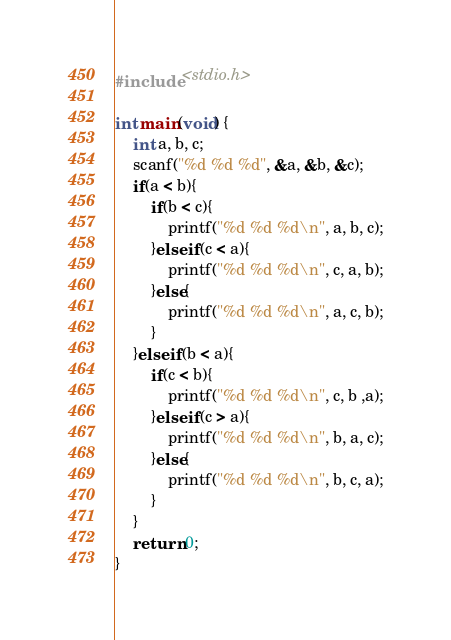Convert code to text. <code><loc_0><loc_0><loc_500><loc_500><_C_>#include <stdio.h>

int main(void) {
	int a, b, c;
	scanf("%d %d %d", &a, &b, &c);
	if(a < b){
		if(b < c){
			printf("%d %d %d\n", a, b, c);
		}else if(c < a){
			printf("%d %d %d\n", c, a, b);
		}else{
			printf("%d %d %d\n", a, c, b);
		}
	}else if(b < a){
		if(c < b){
			printf("%d %d %d\n", c, b ,a);
		}else if(c > a){
			printf("%d %d %d\n", b, a, c);
		}else{
			printf("%d %d %d\n", b, c, a);
		}
	}
	return 0;
}
</code> 